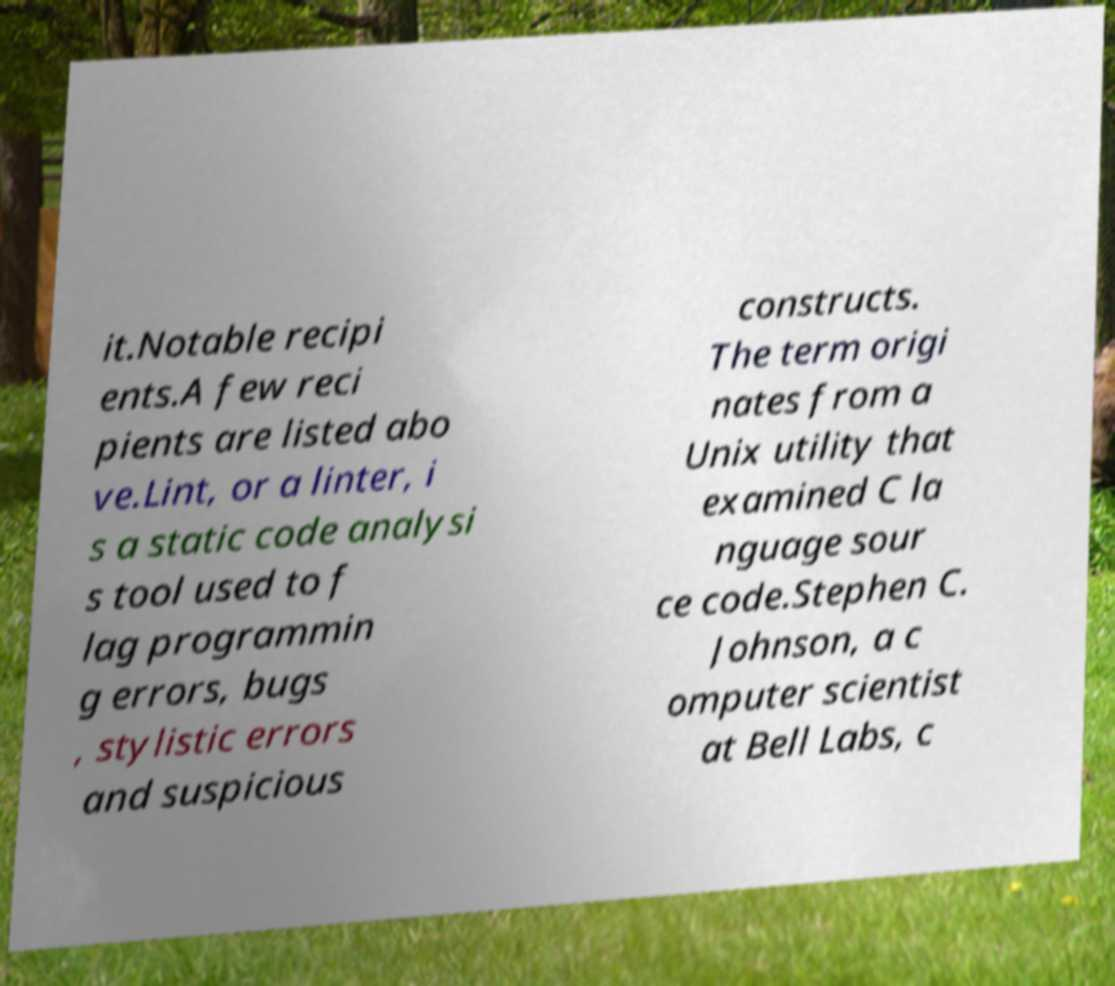I need the written content from this picture converted into text. Can you do that? it.Notable recipi ents.A few reci pients are listed abo ve.Lint, or a linter, i s a static code analysi s tool used to f lag programmin g errors, bugs , stylistic errors and suspicious constructs. The term origi nates from a Unix utility that examined C la nguage sour ce code.Stephen C. Johnson, a c omputer scientist at Bell Labs, c 